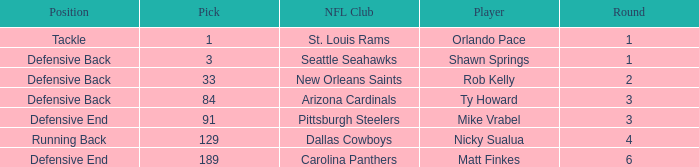Would you mind parsing the complete table? {'header': ['Position', 'Pick', 'NFL Club', 'Player', 'Round'], 'rows': [['Tackle', '1', 'St. Louis Rams', 'Orlando Pace', '1'], ['Defensive Back', '3', 'Seattle Seahawks', 'Shawn Springs', '1'], ['Defensive Back', '33', 'New Orleans Saints', 'Rob Kelly', '2'], ['Defensive Back', '84', 'Arizona Cardinals', 'Ty Howard', '3'], ['Defensive End', '91', 'Pittsburgh Steelers', 'Mike Vrabel', '3'], ['Running Back', '129', 'Dallas Cowboys', 'Nicky Sualua', '4'], ['Defensive End', '189', 'Carolina Panthers', 'Matt Finkes', '6']]} What round has a pick less than 189, with arizona cardinals as the NFL club? 3.0. 